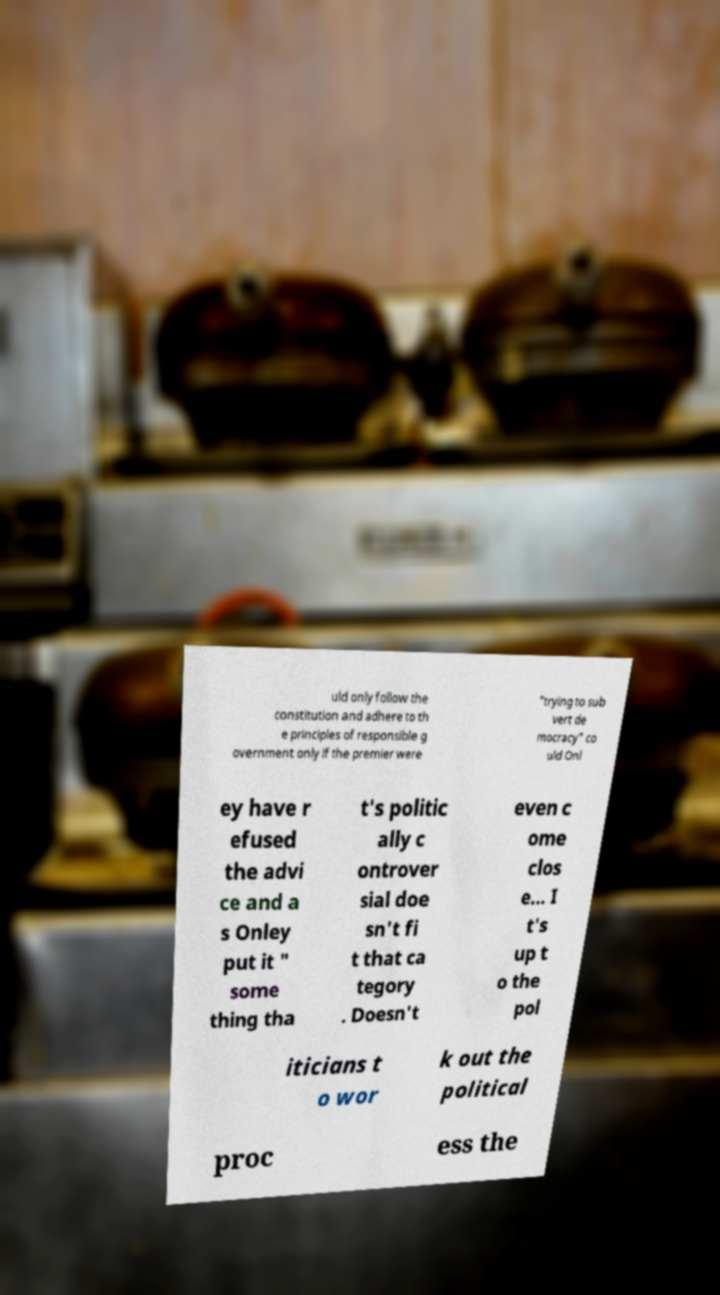Please read and relay the text visible in this image. What does it say? uld only follow the constitution and adhere to th e principles of responsible g overnment only if the premier were "trying to sub vert de mocracy" co uld Onl ey have r efused the advi ce and a s Onley put it " some thing tha t's politic ally c ontrover sial doe sn't fi t that ca tegory . Doesn't even c ome clos e... I t's up t o the pol iticians t o wor k out the political proc ess the 